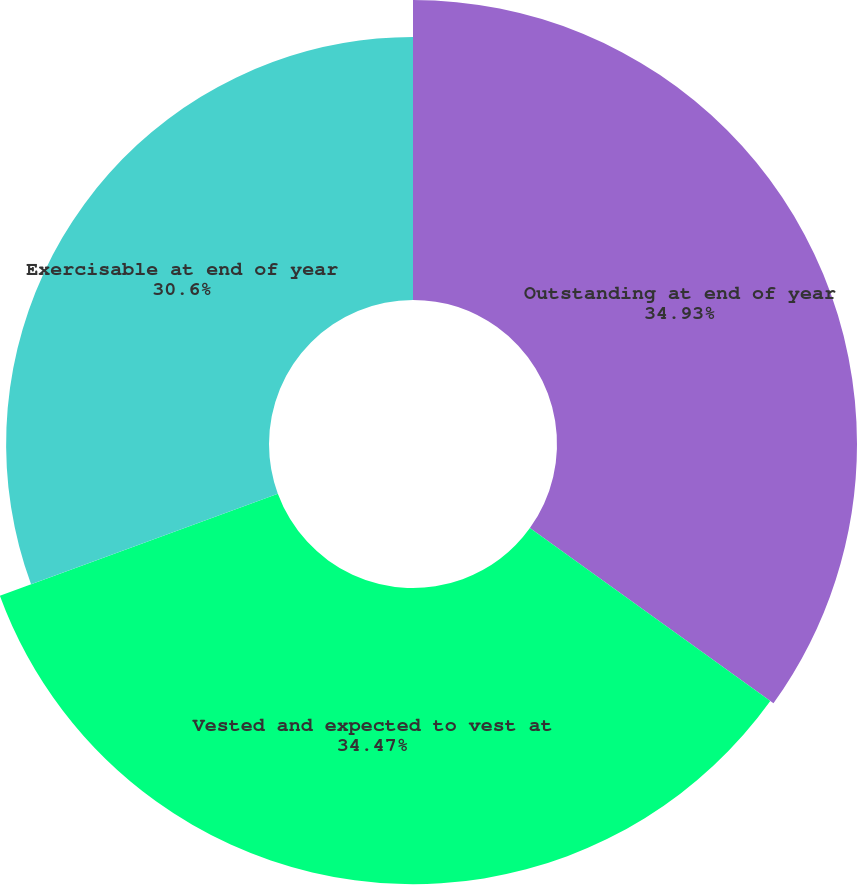Convert chart. <chart><loc_0><loc_0><loc_500><loc_500><pie_chart><fcel>Outstanding at end of year<fcel>Vested and expected to vest at<fcel>Exercisable at end of year<nl><fcel>34.92%<fcel>34.47%<fcel>30.6%<nl></chart> 